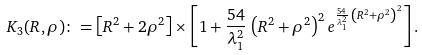<formula> <loc_0><loc_0><loc_500><loc_500>K _ { 3 } ( R , \rho ) \colon = \left [ R ^ { 2 } + 2 \rho ^ { 2 } \right ] \times \left [ 1 + \frac { 5 4 } { \lambda _ { 1 } ^ { 2 } } \, \left ( R ^ { 2 } + \rho ^ { 2 } \right ) ^ { 2 } e ^ { \frac { 5 4 } { \lambda _ { 1 } ^ { 2 } } \, \left ( R ^ { 2 } + \rho ^ { 2 } \right ) ^ { 2 } } \right ] .</formula> 